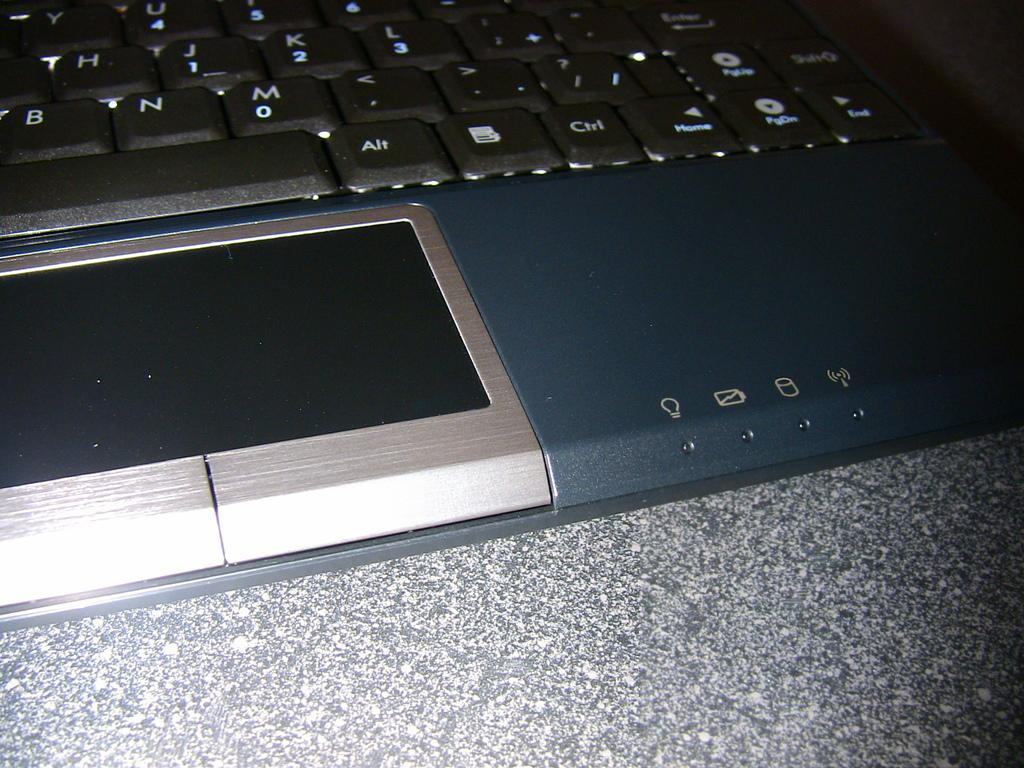<image>
Present a compact description of the photo's key features. an close up of a key board with keys like Ctrl and M 